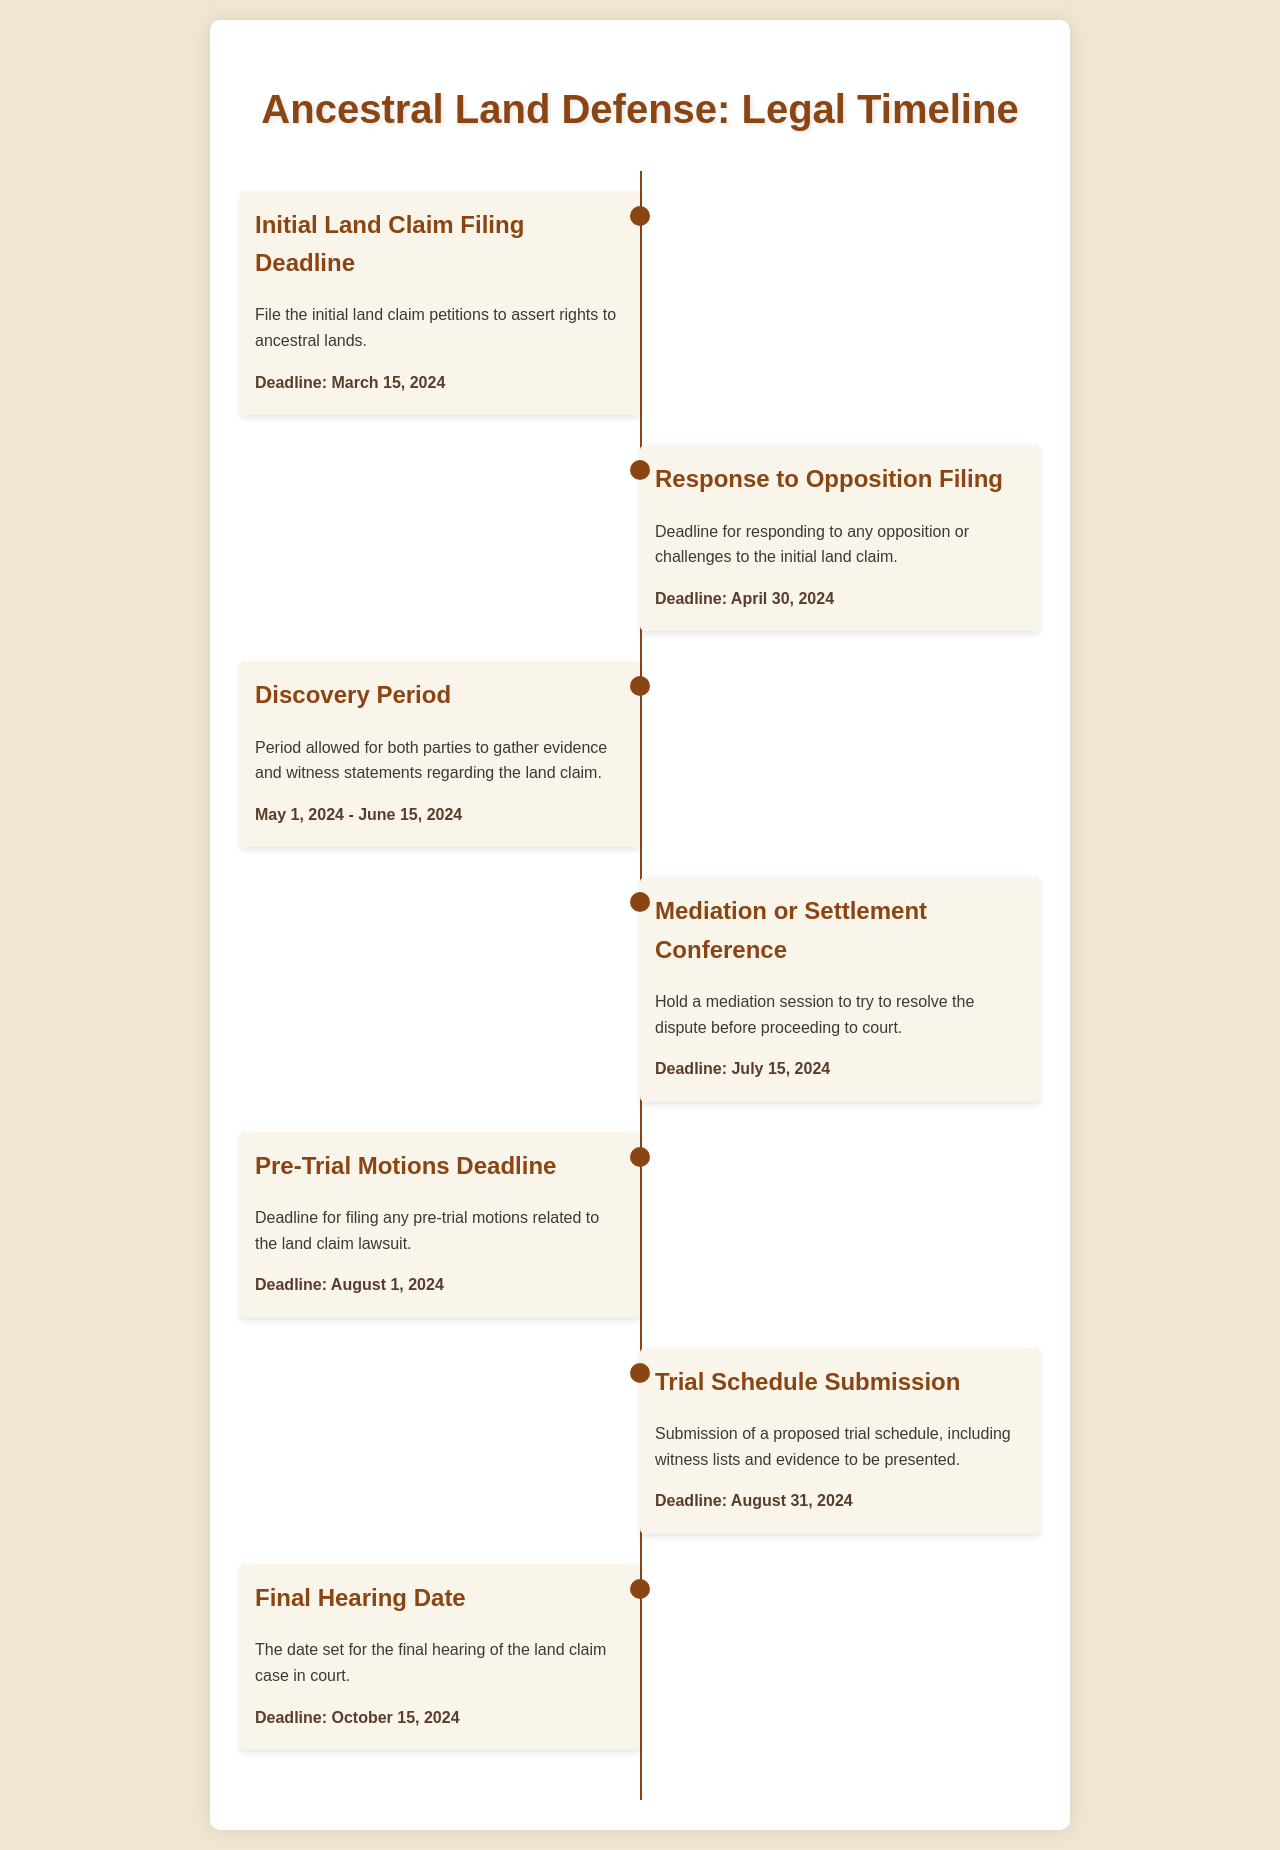What is the initial land claim filing deadline? The document states that the initial land claim petitions must be filed by March 15, 2024.
Answer: March 15, 2024 When is the deadline for responding to opposition filings? The document indicates that the response to opposition filing must be completed by April 30, 2024.
Answer: April 30, 2024 What period does the discovery phase cover? The document specifies that the discovery period runs from May 1, 2024, to June 15, 2024.
Answer: May 1, 2024 - June 15, 2024 What is the deadline for the mediation or settlement conference? According to the document, the mediation session must be held by July 15, 2024.
Answer: July 15, 2024 How many events are listed in the schedule? The document outlines a total of seven events related to the legal timeline for ancestral land defense.
Answer: Seven What is the final hearing date for the land claim case? The document mentions that the final hearing date is set for October 15, 2024.
Answer: October 15, 2024 What must be submitted by August 31, 2024? The document states a proposed trial schedule, including witness lists and evidence, must be submitted by this date.
Answer: Trial schedule submission What type of legal action is addressed in this document? The document pertains to legal actions related to land claims and lawsuits.
Answer: Land claims 